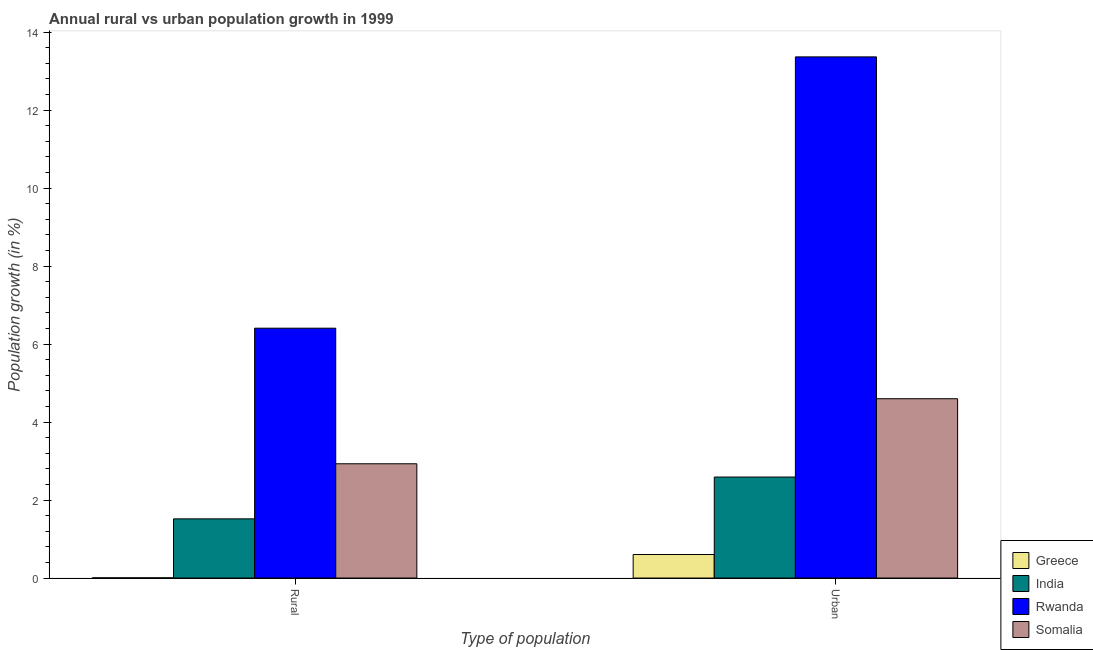What is the label of the 1st group of bars from the left?
Your response must be concise. Rural. What is the rural population growth in Rwanda?
Provide a short and direct response. 6.41. Across all countries, what is the maximum urban population growth?
Provide a succinct answer. 13.36. Across all countries, what is the minimum rural population growth?
Keep it short and to the point. 0.01. In which country was the rural population growth maximum?
Provide a succinct answer. Rwanda. In which country was the urban population growth minimum?
Provide a succinct answer. Greece. What is the total urban population growth in the graph?
Make the answer very short. 21.15. What is the difference between the urban population growth in India and that in Rwanda?
Ensure brevity in your answer.  -10.77. What is the difference between the urban population growth in Greece and the rural population growth in Somalia?
Provide a succinct answer. -2.33. What is the average urban population growth per country?
Give a very brief answer. 5.29. What is the difference between the rural population growth and urban population growth in Somalia?
Your response must be concise. -1.67. In how many countries, is the urban population growth greater than 5.6 %?
Give a very brief answer. 1. What is the ratio of the urban population growth in Greece to that in India?
Make the answer very short. 0.23. What does the 3rd bar from the left in Urban  represents?
Keep it short and to the point. Rwanda. What does the 1st bar from the right in Urban  represents?
Keep it short and to the point. Somalia. How many bars are there?
Make the answer very short. 8. How many countries are there in the graph?
Your answer should be very brief. 4. What is the difference between two consecutive major ticks on the Y-axis?
Keep it short and to the point. 2. Are the values on the major ticks of Y-axis written in scientific E-notation?
Your answer should be very brief. No. Does the graph contain grids?
Give a very brief answer. No. What is the title of the graph?
Make the answer very short. Annual rural vs urban population growth in 1999. What is the label or title of the X-axis?
Make the answer very short. Type of population. What is the label or title of the Y-axis?
Your answer should be compact. Population growth (in %). What is the Population growth (in %) of Greece in Rural?
Your answer should be very brief. 0.01. What is the Population growth (in %) in India in Rural?
Offer a very short reply. 1.52. What is the Population growth (in %) of Rwanda in Rural?
Offer a very short reply. 6.41. What is the Population growth (in %) of Somalia in Rural?
Provide a short and direct response. 2.93. What is the Population growth (in %) of Greece in Urban ?
Provide a succinct answer. 0.6. What is the Population growth (in %) in India in Urban ?
Make the answer very short. 2.59. What is the Population growth (in %) in Rwanda in Urban ?
Offer a very short reply. 13.36. What is the Population growth (in %) in Somalia in Urban ?
Make the answer very short. 4.6. Across all Type of population, what is the maximum Population growth (in %) of Greece?
Your response must be concise. 0.6. Across all Type of population, what is the maximum Population growth (in %) in India?
Make the answer very short. 2.59. Across all Type of population, what is the maximum Population growth (in %) of Rwanda?
Your answer should be compact. 13.36. Across all Type of population, what is the maximum Population growth (in %) in Somalia?
Ensure brevity in your answer.  4.6. Across all Type of population, what is the minimum Population growth (in %) of Greece?
Keep it short and to the point. 0.01. Across all Type of population, what is the minimum Population growth (in %) of India?
Give a very brief answer. 1.52. Across all Type of population, what is the minimum Population growth (in %) in Rwanda?
Ensure brevity in your answer.  6.41. Across all Type of population, what is the minimum Population growth (in %) in Somalia?
Give a very brief answer. 2.93. What is the total Population growth (in %) in Greece in the graph?
Keep it short and to the point. 0.61. What is the total Population growth (in %) in India in the graph?
Offer a very short reply. 4.11. What is the total Population growth (in %) in Rwanda in the graph?
Offer a very short reply. 19.77. What is the total Population growth (in %) in Somalia in the graph?
Provide a succinct answer. 7.53. What is the difference between the Population growth (in %) of Greece in Rural and that in Urban ?
Offer a very short reply. -0.6. What is the difference between the Population growth (in %) of India in Rural and that in Urban ?
Make the answer very short. -1.07. What is the difference between the Population growth (in %) of Rwanda in Rural and that in Urban ?
Provide a short and direct response. -6.96. What is the difference between the Population growth (in %) in Somalia in Rural and that in Urban ?
Make the answer very short. -1.67. What is the difference between the Population growth (in %) of Greece in Rural and the Population growth (in %) of India in Urban?
Provide a succinct answer. -2.58. What is the difference between the Population growth (in %) in Greece in Rural and the Population growth (in %) in Rwanda in Urban?
Make the answer very short. -13.36. What is the difference between the Population growth (in %) in Greece in Rural and the Population growth (in %) in Somalia in Urban?
Provide a succinct answer. -4.59. What is the difference between the Population growth (in %) in India in Rural and the Population growth (in %) in Rwanda in Urban?
Make the answer very short. -11.85. What is the difference between the Population growth (in %) of India in Rural and the Population growth (in %) of Somalia in Urban?
Make the answer very short. -3.08. What is the difference between the Population growth (in %) of Rwanda in Rural and the Population growth (in %) of Somalia in Urban?
Your answer should be very brief. 1.81. What is the average Population growth (in %) of Greece per Type of population?
Make the answer very short. 0.3. What is the average Population growth (in %) in India per Type of population?
Offer a terse response. 2.05. What is the average Population growth (in %) in Rwanda per Type of population?
Provide a short and direct response. 9.88. What is the average Population growth (in %) of Somalia per Type of population?
Provide a short and direct response. 3.76. What is the difference between the Population growth (in %) of Greece and Population growth (in %) of India in Rural?
Ensure brevity in your answer.  -1.51. What is the difference between the Population growth (in %) in Greece and Population growth (in %) in Rwanda in Rural?
Ensure brevity in your answer.  -6.4. What is the difference between the Population growth (in %) in Greece and Population growth (in %) in Somalia in Rural?
Provide a succinct answer. -2.92. What is the difference between the Population growth (in %) of India and Population growth (in %) of Rwanda in Rural?
Offer a very short reply. -4.89. What is the difference between the Population growth (in %) in India and Population growth (in %) in Somalia in Rural?
Keep it short and to the point. -1.41. What is the difference between the Population growth (in %) in Rwanda and Population growth (in %) in Somalia in Rural?
Your answer should be very brief. 3.48. What is the difference between the Population growth (in %) in Greece and Population growth (in %) in India in Urban ?
Give a very brief answer. -1.99. What is the difference between the Population growth (in %) in Greece and Population growth (in %) in Rwanda in Urban ?
Give a very brief answer. -12.76. What is the difference between the Population growth (in %) of Greece and Population growth (in %) of Somalia in Urban ?
Your answer should be very brief. -3.99. What is the difference between the Population growth (in %) of India and Population growth (in %) of Rwanda in Urban ?
Provide a succinct answer. -10.77. What is the difference between the Population growth (in %) in India and Population growth (in %) in Somalia in Urban ?
Your response must be concise. -2.01. What is the difference between the Population growth (in %) of Rwanda and Population growth (in %) of Somalia in Urban ?
Ensure brevity in your answer.  8.77. What is the ratio of the Population growth (in %) of Greece in Rural to that in Urban ?
Your answer should be very brief. 0.01. What is the ratio of the Population growth (in %) in India in Rural to that in Urban ?
Provide a short and direct response. 0.59. What is the ratio of the Population growth (in %) in Rwanda in Rural to that in Urban ?
Keep it short and to the point. 0.48. What is the ratio of the Population growth (in %) in Somalia in Rural to that in Urban ?
Give a very brief answer. 0.64. What is the difference between the highest and the second highest Population growth (in %) in Greece?
Provide a succinct answer. 0.6. What is the difference between the highest and the second highest Population growth (in %) in India?
Your answer should be compact. 1.07. What is the difference between the highest and the second highest Population growth (in %) of Rwanda?
Your response must be concise. 6.96. What is the difference between the highest and the second highest Population growth (in %) in Somalia?
Your response must be concise. 1.67. What is the difference between the highest and the lowest Population growth (in %) of Greece?
Ensure brevity in your answer.  0.6. What is the difference between the highest and the lowest Population growth (in %) of India?
Ensure brevity in your answer.  1.07. What is the difference between the highest and the lowest Population growth (in %) of Rwanda?
Provide a succinct answer. 6.96. What is the difference between the highest and the lowest Population growth (in %) in Somalia?
Give a very brief answer. 1.67. 